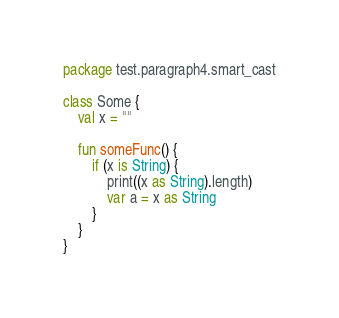Convert code to text. <code><loc_0><loc_0><loc_500><loc_500><_Kotlin_>package test.paragraph4.smart_cast

class Some {
    val x = ""

    fun someFunc() {
        if (x is String) {
            print((x as String).length)
            var a = x as String
        }
    }
}
</code> 